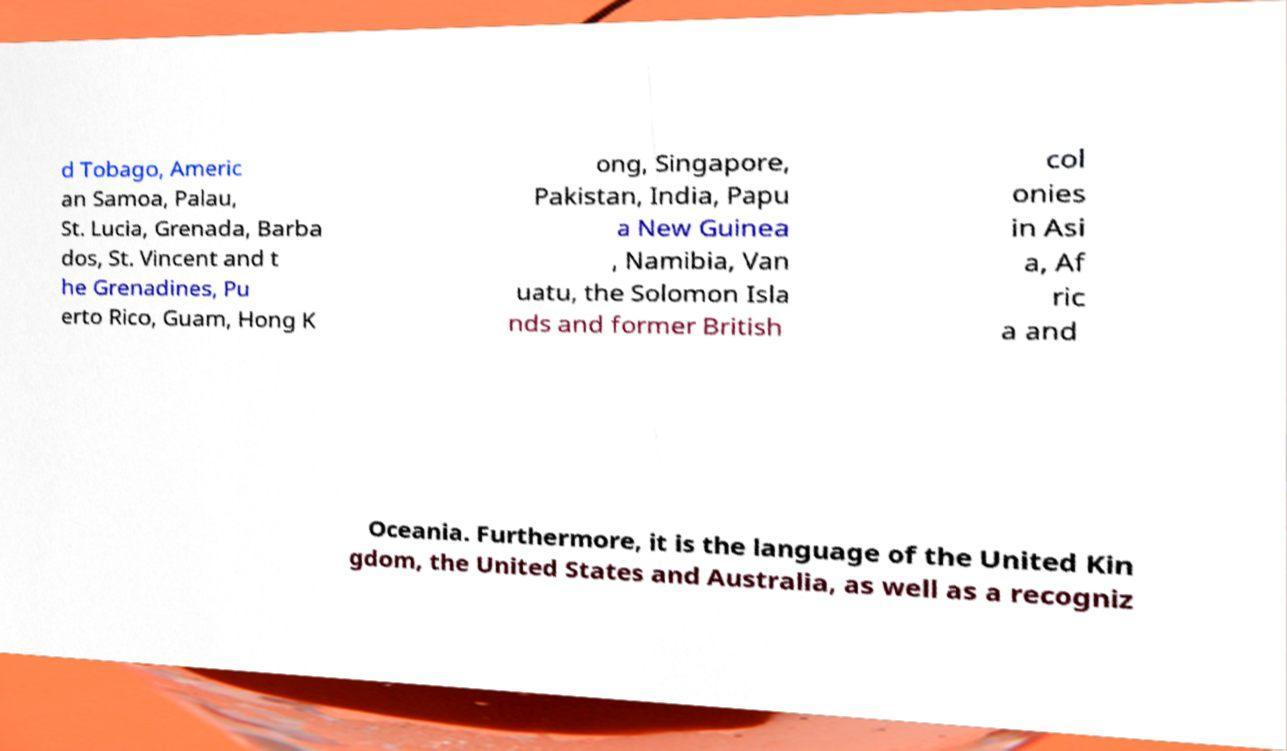Please identify and transcribe the text found in this image. d Tobago, Americ an Samoa, Palau, St. Lucia, Grenada, Barba dos, St. Vincent and t he Grenadines, Pu erto Rico, Guam, Hong K ong, Singapore, Pakistan, India, Papu a New Guinea , Namibia, Van uatu, the Solomon Isla nds and former British col onies in Asi a, Af ric a and Oceania. Furthermore, it is the language of the United Kin gdom, the United States and Australia, as well as a recogniz 